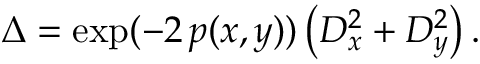<formula> <loc_0><loc_0><loc_500><loc_500>\Delta = \exp ( - 2 \, p ( x , y ) ) \left ( D _ { x } ^ { 2 } + D _ { y } ^ { 2 } \right ) .</formula> 